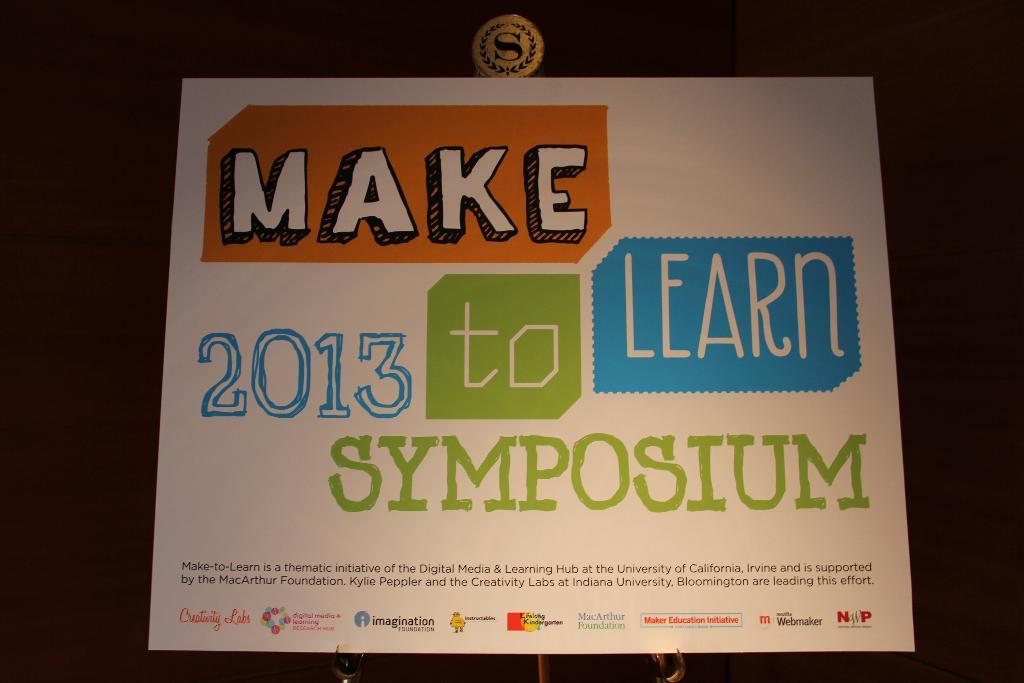What year is the symposium?
Your answer should be very brief. 2013. 